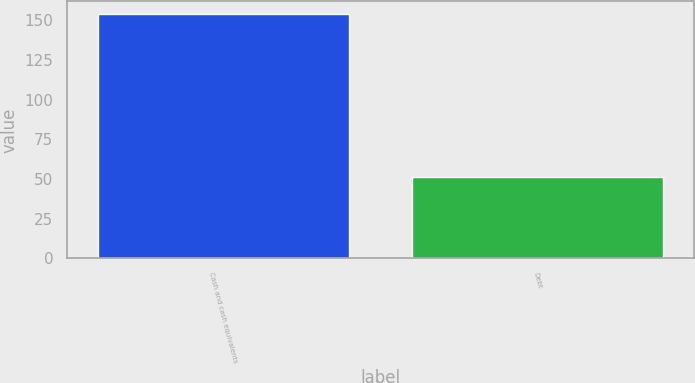<chart> <loc_0><loc_0><loc_500><loc_500><bar_chart><fcel>Cash and cash equivalents<fcel>Debt<nl><fcel>154.2<fcel>51<nl></chart> 